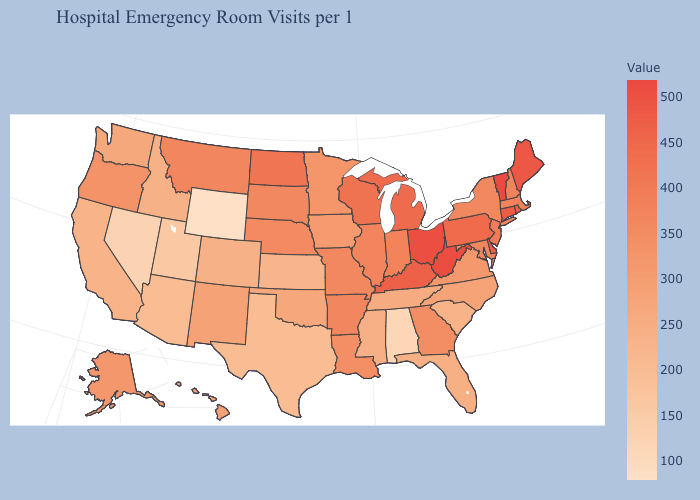Among the states that border South Carolina , does North Carolina have the highest value?
Short answer required. No. Which states hav the highest value in the South?
Give a very brief answer. West Virginia. Which states have the lowest value in the Northeast?
Quick response, please. New York. Does Connecticut have the highest value in the Northeast?
Concise answer only. No. Does the map have missing data?
Quick response, please. No. Does New Mexico have a higher value than Georgia?
Concise answer only. No. 